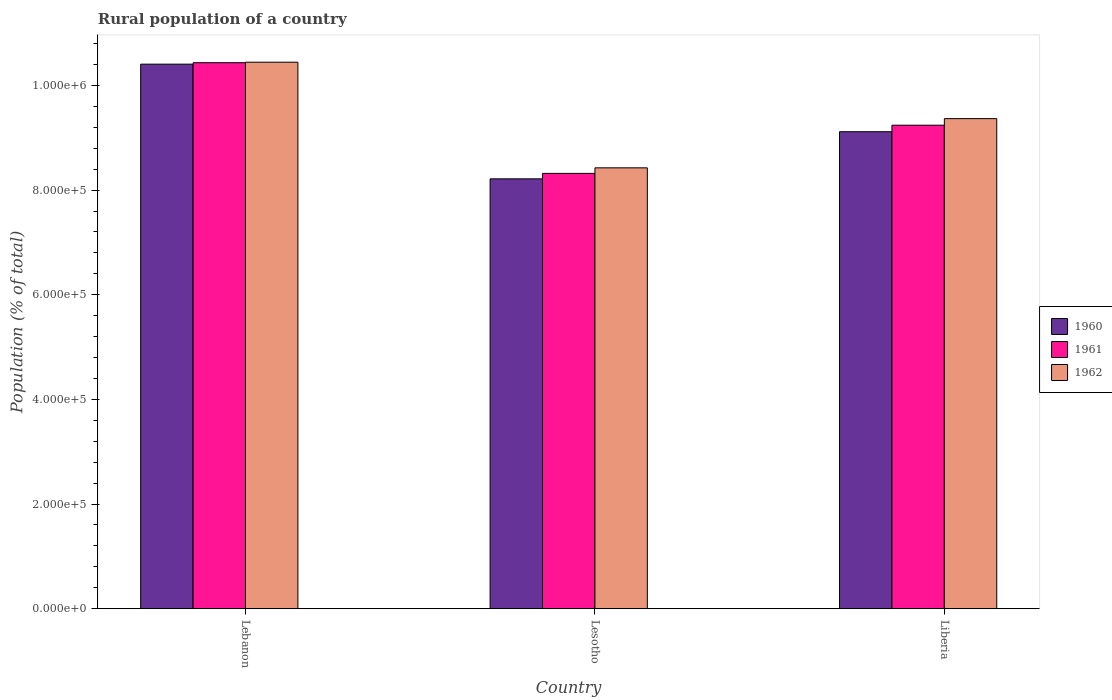Are the number of bars per tick equal to the number of legend labels?
Give a very brief answer. Yes. How many bars are there on the 3rd tick from the left?
Provide a succinct answer. 3. What is the label of the 2nd group of bars from the left?
Offer a terse response. Lesotho. What is the rural population in 1962 in Lesotho?
Give a very brief answer. 8.43e+05. Across all countries, what is the maximum rural population in 1962?
Your answer should be compact. 1.04e+06. Across all countries, what is the minimum rural population in 1961?
Your answer should be very brief. 8.32e+05. In which country was the rural population in 1962 maximum?
Give a very brief answer. Lebanon. In which country was the rural population in 1960 minimum?
Your response must be concise. Lesotho. What is the total rural population in 1961 in the graph?
Offer a very short reply. 2.80e+06. What is the difference between the rural population in 1960 in Lebanon and that in Liberia?
Give a very brief answer. 1.29e+05. What is the difference between the rural population in 1961 in Lesotho and the rural population in 1960 in Lebanon?
Ensure brevity in your answer.  -2.09e+05. What is the average rural population in 1961 per country?
Give a very brief answer. 9.33e+05. What is the difference between the rural population of/in 1960 and rural population of/in 1962 in Lebanon?
Offer a terse response. -3757. What is the ratio of the rural population in 1961 in Lesotho to that in Liberia?
Ensure brevity in your answer.  0.9. What is the difference between the highest and the second highest rural population in 1962?
Give a very brief answer. 1.08e+05. What is the difference between the highest and the lowest rural population in 1960?
Ensure brevity in your answer.  2.19e+05. In how many countries, is the rural population in 1962 greater than the average rural population in 1962 taken over all countries?
Your answer should be very brief. 1. Is the sum of the rural population in 1961 in Lebanon and Liberia greater than the maximum rural population in 1962 across all countries?
Ensure brevity in your answer.  Yes. What does the 2nd bar from the right in Lebanon represents?
Your answer should be compact. 1961. Are all the bars in the graph horizontal?
Offer a very short reply. No. Are the values on the major ticks of Y-axis written in scientific E-notation?
Your answer should be compact. Yes. Does the graph contain any zero values?
Keep it short and to the point. No. Does the graph contain grids?
Provide a short and direct response. No. How many legend labels are there?
Make the answer very short. 3. What is the title of the graph?
Offer a very short reply. Rural population of a country. Does "2012" appear as one of the legend labels in the graph?
Keep it short and to the point. No. What is the label or title of the X-axis?
Give a very brief answer. Country. What is the label or title of the Y-axis?
Offer a very short reply. Population (% of total). What is the Population (% of total) in 1960 in Lebanon?
Provide a short and direct response. 1.04e+06. What is the Population (% of total) of 1961 in Lebanon?
Offer a very short reply. 1.04e+06. What is the Population (% of total) of 1962 in Lebanon?
Ensure brevity in your answer.  1.04e+06. What is the Population (% of total) in 1960 in Lesotho?
Offer a terse response. 8.22e+05. What is the Population (% of total) in 1961 in Lesotho?
Ensure brevity in your answer.  8.32e+05. What is the Population (% of total) of 1962 in Lesotho?
Provide a succinct answer. 8.43e+05. What is the Population (% of total) of 1960 in Liberia?
Keep it short and to the point. 9.12e+05. What is the Population (% of total) in 1961 in Liberia?
Ensure brevity in your answer.  9.24e+05. What is the Population (% of total) in 1962 in Liberia?
Your answer should be compact. 9.37e+05. Across all countries, what is the maximum Population (% of total) in 1960?
Keep it short and to the point. 1.04e+06. Across all countries, what is the maximum Population (% of total) of 1961?
Offer a terse response. 1.04e+06. Across all countries, what is the maximum Population (% of total) in 1962?
Offer a very short reply. 1.04e+06. Across all countries, what is the minimum Population (% of total) of 1960?
Keep it short and to the point. 8.22e+05. Across all countries, what is the minimum Population (% of total) in 1961?
Your answer should be very brief. 8.32e+05. Across all countries, what is the minimum Population (% of total) of 1962?
Ensure brevity in your answer.  8.43e+05. What is the total Population (% of total) in 1960 in the graph?
Give a very brief answer. 2.77e+06. What is the total Population (% of total) of 1961 in the graph?
Offer a very short reply. 2.80e+06. What is the total Population (% of total) of 1962 in the graph?
Provide a short and direct response. 2.82e+06. What is the difference between the Population (% of total) of 1960 in Lebanon and that in Lesotho?
Ensure brevity in your answer.  2.19e+05. What is the difference between the Population (% of total) of 1961 in Lebanon and that in Lesotho?
Keep it short and to the point. 2.12e+05. What is the difference between the Population (% of total) of 1962 in Lebanon and that in Lesotho?
Your answer should be compact. 2.02e+05. What is the difference between the Population (% of total) of 1960 in Lebanon and that in Liberia?
Offer a very short reply. 1.29e+05. What is the difference between the Population (% of total) of 1961 in Lebanon and that in Liberia?
Your answer should be very brief. 1.19e+05. What is the difference between the Population (% of total) in 1962 in Lebanon and that in Liberia?
Keep it short and to the point. 1.08e+05. What is the difference between the Population (% of total) in 1960 in Lesotho and that in Liberia?
Your answer should be very brief. -9.01e+04. What is the difference between the Population (% of total) in 1961 in Lesotho and that in Liberia?
Your answer should be compact. -9.21e+04. What is the difference between the Population (% of total) of 1962 in Lesotho and that in Liberia?
Your answer should be very brief. -9.40e+04. What is the difference between the Population (% of total) of 1960 in Lebanon and the Population (% of total) of 1961 in Lesotho?
Provide a succinct answer. 2.09e+05. What is the difference between the Population (% of total) of 1960 in Lebanon and the Population (% of total) of 1962 in Lesotho?
Ensure brevity in your answer.  1.98e+05. What is the difference between the Population (% of total) in 1961 in Lebanon and the Population (% of total) in 1962 in Lesotho?
Make the answer very short. 2.01e+05. What is the difference between the Population (% of total) of 1960 in Lebanon and the Population (% of total) of 1961 in Liberia?
Your response must be concise. 1.17e+05. What is the difference between the Population (% of total) of 1960 in Lebanon and the Population (% of total) of 1962 in Liberia?
Offer a very short reply. 1.04e+05. What is the difference between the Population (% of total) of 1961 in Lebanon and the Population (% of total) of 1962 in Liberia?
Provide a succinct answer. 1.07e+05. What is the difference between the Population (% of total) of 1960 in Lesotho and the Population (% of total) of 1961 in Liberia?
Ensure brevity in your answer.  -1.03e+05. What is the difference between the Population (% of total) of 1960 in Lesotho and the Population (% of total) of 1962 in Liberia?
Make the answer very short. -1.15e+05. What is the difference between the Population (% of total) of 1961 in Lesotho and the Population (% of total) of 1962 in Liberia?
Your answer should be compact. -1.05e+05. What is the average Population (% of total) in 1960 per country?
Offer a very short reply. 9.25e+05. What is the average Population (% of total) of 1961 per country?
Give a very brief answer. 9.33e+05. What is the average Population (% of total) in 1962 per country?
Keep it short and to the point. 9.41e+05. What is the difference between the Population (% of total) of 1960 and Population (% of total) of 1961 in Lebanon?
Make the answer very short. -2785. What is the difference between the Population (% of total) of 1960 and Population (% of total) of 1962 in Lebanon?
Give a very brief answer. -3757. What is the difference between the Population (% of total) in 1961 and Population (% of total) in 1962 in Lebanon?
Provide a short and direct response. -972. What is the difference between the Population (% of total) of 1960 and Population (% of total) of 1961 in Lesotho?
Keep it short and to the point. -1.04e+04. What is the difference between the Population (% of total) in 1960 and Population (% of total) in 1962 in Lesotho?
Give a very brief answer. -2.10e+04. What is the difference between the Population (% of total) in 1961 and Population (% of total) in 1962 in Lesotho?
Your answer should be very brief. -1.06e+04. What is the difference between the Population (% of total) in 1960 and Population (% of total) in 1961 in Liberia?
Your answer should be very brief. -1.25e+04. What is the difference between the Population (% of total) in 1960 and Population (% of total) in 1962 in Liberia?
Your answer should be compact. -2.50e+04. What is the difference between the Population (% of total) of 1961 and Population (% of total) of 1962 in Liberia?
Make the answer very short. -1.25e+04. What is the ratio of the Population (% of total) in 1960 in Lebanon to that in Lesotho?
Keep it short and to the point. 1.27. What is the ratio of the Population (% of total) in 1961 in Lebanon to that in Lesotho?
Your response must be concise. 1.25. What is the ratio of the Population (% of total) of 1962 in Lebanon to that in Lesotho?
Your answer should be compact. 1.24. What is the ratio of the Population (% of total) in 1960 in Lebanon to that in Liberia?
Provide a short and direct response. 1.14. What is the ratio of the Population (% of total) of 1961 in Lebanon to that in Liberia?
Your answer should be compact. 1.13. What is the ratio of the Population (% of total) in 1962 in Lebanon to that in Liberia?
Keep it short and to the point. 1.12. What is the ratio of the Population (% of total) of 1960 in Lesotho to that in Liberia?
Your response must be concise. 0.9. What is the ratio of the Population (% of total) in 1961 in Lesotho to that in Liberia?
Give a very brief answer. 0.9. What is the ratio of the Population (% of total) in 1962 in Lesotho to that in Liberia?
Offer a terse response. 0.9. What is the difference between the highest and the second highest Population (% of total) of 1960?
Give a very brief answer. 1.29e+05. What is the difference between the highest and the second highest Population (% of total) of 1961?
Ensure brevity in your answer.  1.19e+05. What is the difference between the highest and the second highest Population (% of total) in 1962?
Your answer should be compact. 1.08e+05. What is the difference between the highest and the lowest Population (% of total) in 1960?
Offer a terse response. 2.19e+05. What is the difference between the highest and the lowest Population (% of total) in 1961?
Offer a terse response. 2.12e+05. What is the difference between the highest and the lowest Population (% of total) in 1962?
Your answer should be very brief. 2.02e+05. 